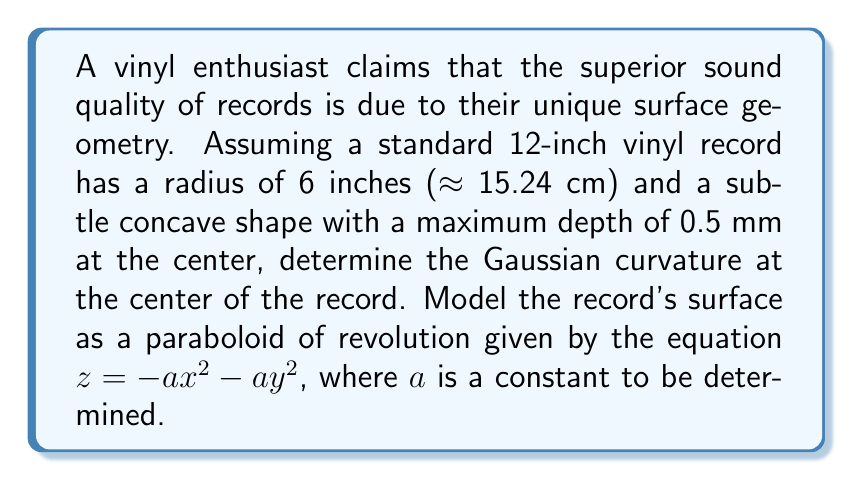Solve this math problem. Let's approach this step-by-step:

1) First, we need to determine the value of $a$ in the equation $z = -ax^2 - ay^2$. We know that at the edge of the record (r = 6 inches = 15.24 cm), z = 0, and at the center, z = -0.5 mm = -0.05 cm.

   At the edge: $0 = -a(15.24^2) - a(0^2)$
                $a = \frac{0.05}{15.24^2} \approx 2.15 \times 10^{-4} \text{ cm}^{-1}$

2) Now we have the surface equation: $z = -2.15 \times 10^{-4}(x^2 + y^2)$

3) To find the Gaussian curvature, we need to calculate the coefficients of the first and second fundamental forms. For a surface of the form $z = f(x,y)$:

   $E = 1 + (\frac{\partial z}{\partial x})^2$
   $F = \frac{\partial z}{\partial x} \frac{\partial z}{\partial y}$
   $G = 1 + (\frac{\partial z}{\partial y})^2$
   $L = \frac{\partial^2 z}{\partial x^2} / \sqrt{1 + (\frac{\partial z}{\partial x})^2 + (\frac{\partial z}{\partial y})^2}$
   $M = \frac{\partial^2 z}{\partial x \partial y} / \sqrt{1 + (\frac{\partial z}{\partial x})^2 + (\frac{\partial z}{\partial y})^2}$
   $N = \frac{\partial^2 z}{\partial y^2} / \sqrt{1 + (\frac{\partial z}{\partial x})^2 + (\frac{\partial z}{\partial y})^2}$

4) Calculating these for our surface:

   $\frac{\partial z}{\partial x} = -4.3 \times 10^{-4}x$
   $\frac{\partial z}{\partial y} = -4.3 \times 10^{-4}y$
   $\frac{\partial^2 z}{\partial x^2} = \frac{\partial^2 z}{\partial y^2} = -4.3 \times 10^{-4}$
   $\frac{\partial^2 z}{\partial x \partial y} = 0$

5) At the center of the record (x = 0, y = 0):

   $E = G = 1$, $F = 0$
   $L = N = -4.3 \times 10^{-4}$, $M = 0$

6) The Gaussian curvature K is given by:

   $$K = \frac{LN - M^2}{EG - F^2}$$

7) Substituting our values:

   $$K = \frac{(-4.3 \times 10^{-4})(-4.3 \times 10^{-4}) - 0^2}{(1)(1) - 0^2} = 1.849 \times 10^{-7} \text{ cm}^{-2}$$
Answer: $1.849 \times 10^{-7} \text{ cm}^{-2}$ 